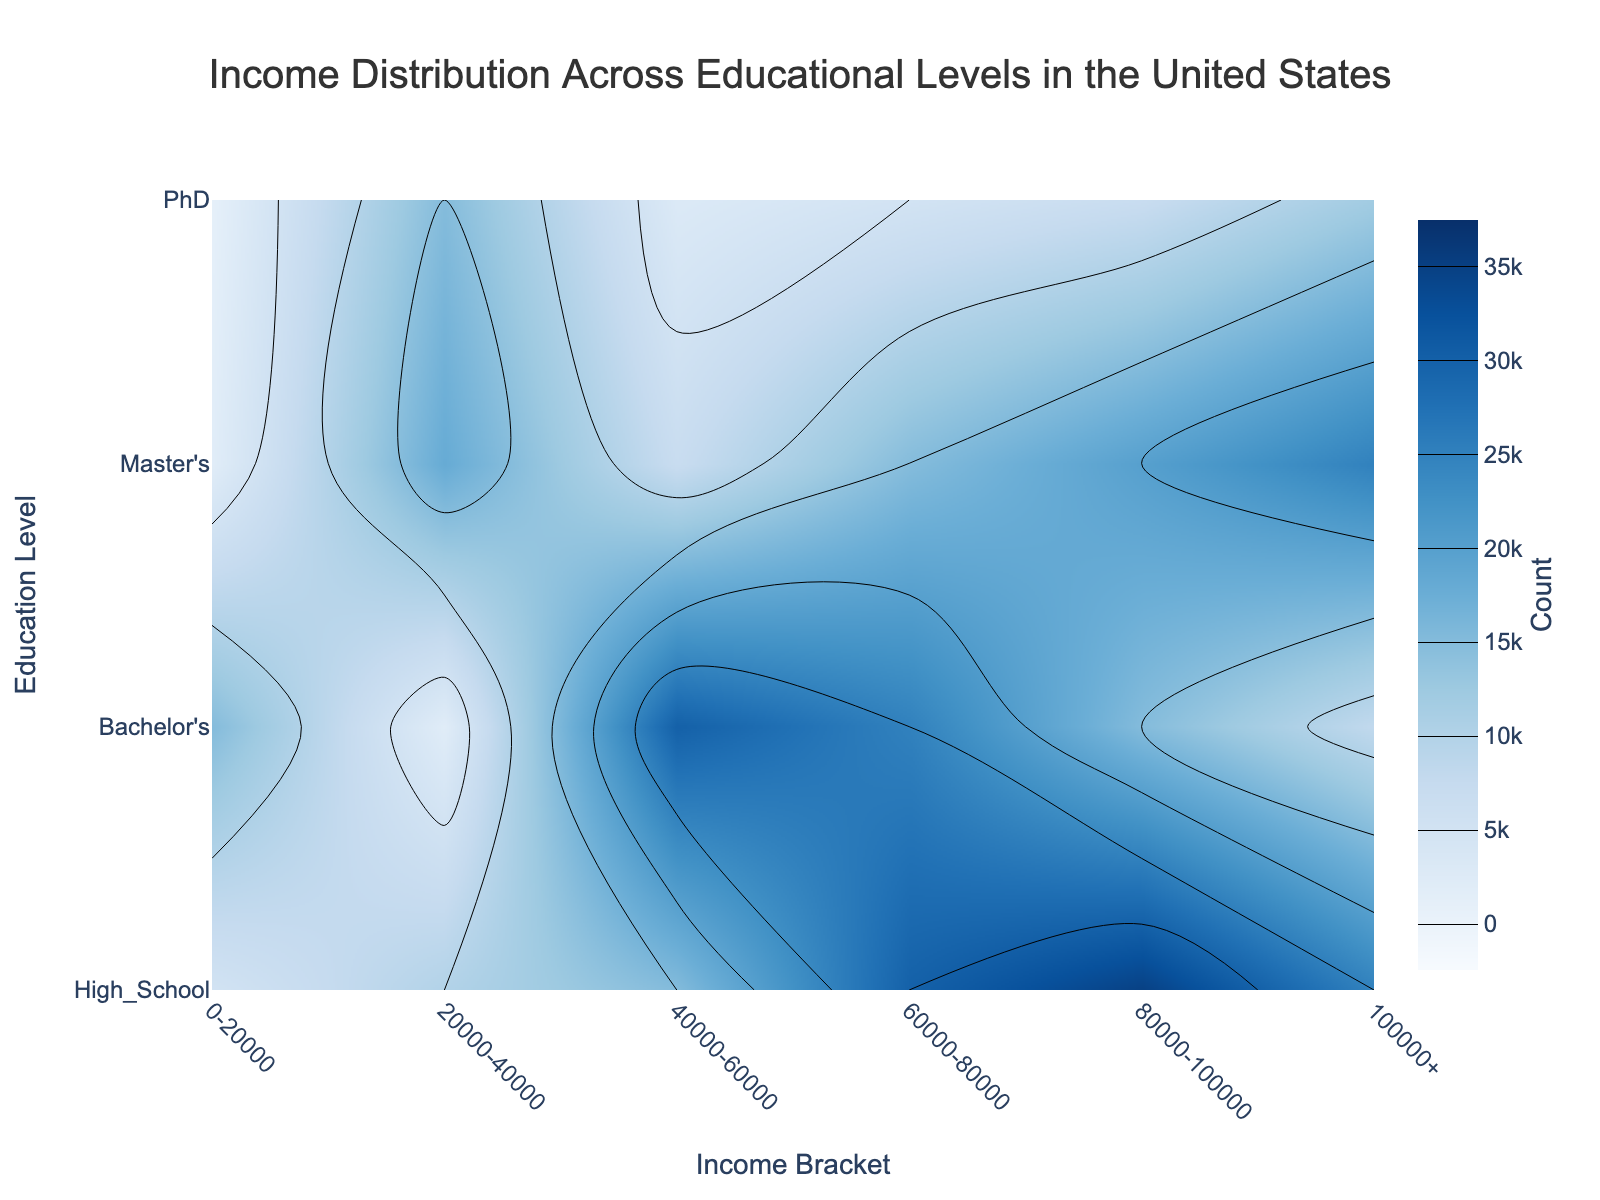What is the title of the plot? The title of the plot is prominently displayed at the top. It summarizes the content of the plot.
Answer: Income Distribution Across Educational Levels in the United States What are the labels on the x-axis and y-axis? The x-axis label represents the income bracket, and the y-axis label represents the education level. These labels are clearly shown along the respective axes.
Answer: Income Bracket and Education Level Which education level has the highest count in the $40,000-$60,000 income bracket? By looking at the contours and the color depth for the $40,000-$60,000 income bracket, we identify which education level segment has the highest value.
Answer: Bachelor's How many income brackets are there in the plot? Counting the different distinct segments along the x-axis will give the number of income brackets plotted.
Answer: 6 Which education level shows a higher income concentration (above $100,000)? We look at the depth of color concentrated in the $100,000+ income bracket and compare it horizontally across the education levels.
Answer: PhD What is the color used for the highest count on the plot, and what does it represent? The deepest color in the contour plot (darkest shade) generally represents the highest count value. This color is derived from the color scale used.
Answer: Dark blue, representing a count of 35,000 Compare the count difference between Bachelor's and PhD in the $20,000-$40,000 income bracket. Retrieve the specific counts for Bachelor's and PhD in the $20,000-$40,000 income bracket and compute the difference between them.
Answer: 12,000 What pattern is observed in income distribution among those with a Master’s degree? Describe the general trend or noticeable patterns in the income distribution for individuals with a Master’s degree by analyzing the contour colors.
Answer: As income increases, the count generally increases, peaking at $80,000-$100,000 before slightly decreasing at $100,000+ Which education level has the lowest overall count, and how do you infer this from the plot? By observing the color intensity across all income brackets for each education level, we can identify which has the lightest average colors, indicating lower counts.
Answer: PhD due to lighter color bands for most income brackets 